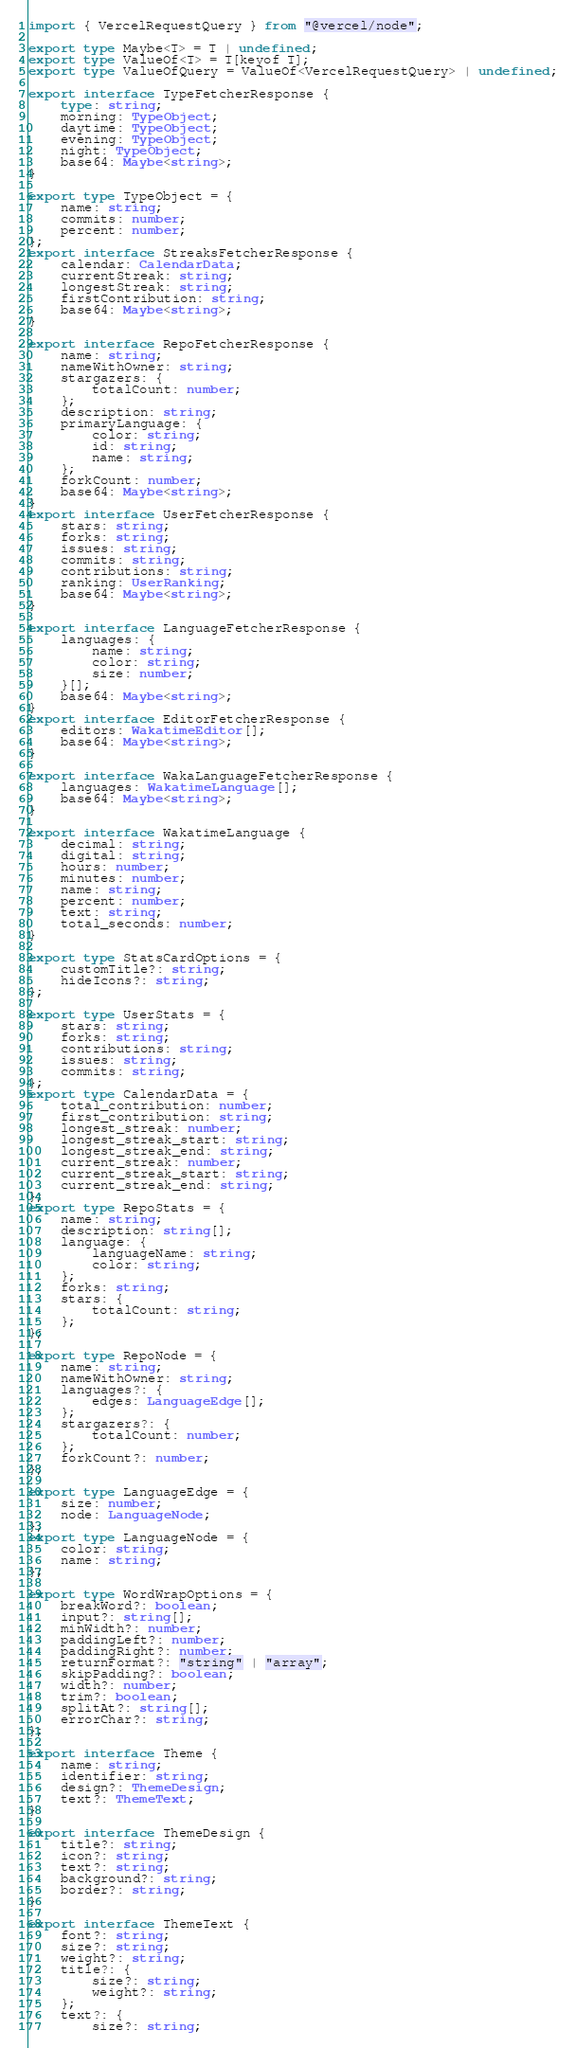Convert code to text. <code><loc_0><loc_0><loc_500><loc_500><_TypeScript_>import { VercelRequestQuery } from "@vercel/node";

export type Maybe<T> = T | undefined;
export type ValueOf<T> = T[keyof T];
export type ValueOfQuery = ValueOf<VercelRequestQuery> | undefined;

export interface TypeFetcherResponse {
    type: string;
    morning: TypeObject;
    daytime: TypeObject;
    evening: TypeObject;
    night: TypeObject;
    base64: Maybe<string>;
}

export type TypeObject = {
    name: string;
    commits: number;
    percent: number;
};
export interface StreaksFetcherResponse {
    calendar: CalendarData;
    currentStreak: string;
    longestStreak: string;
    firstContribution: string;
    base64: Maybe<string>;
}

export interface RepoFetcherResponse {
    name: string;
    nameWithOwner: string;
    stargazers: {
        totalCount: number;
    };
    description: string;
    primaryLanguage: {
        color: string;
        id: string;
        name: string;
    };
    forkCount: number;
    base64: Maybe<string>;
}
export interface UserFetcherResponse {
    stars: string;
    forks: string;
    issues: string;
    commits: string;
    contributions: string;
    ranking: UserRanking;
    base64: Maybe<string>;
}

export interface LanguageFetcherResponse {
    languages: {
        name: string;
        color: string;
        size: number;
    }[];
    base64: Maybe<string>;
}
export interface EditorFetcherResponse {
    editors: WakatimeEditor[];
    base64: Maybe<string>;
}

export interface WakaLanguageFetcherResponse {
    languages: WakatimeLanguage[];
    base64: Maybe<string>;
}

export interface WakatimeLanguage {
    decimal: string;
    digital: string;
    hours: number;
    minutes: number;
    name: string;
    percent: number;
    text: string;
    total_seconds: number;
}

export type StatsCardOptions = {
    customTitle?: string;
    hideIcons?: string;
};

export type UserStats = {
    stars: string;
    forks: string;
    contributions: string;
    issues: string;
    commits: string;
};
export type CalendarData = {
    total_contribution: number;
    first_contribution: string;
    longest_streak: number;
    longest_streak_start: string;
    longest_streak_end: string;
    current_streak: number;
    current_streak_start: string;
    current_streak_end: string;
};
export type RepoStats = {
    name: string;
    description: string[];
    language: {
        languageName: string;
        color: string;
    };
    forks: string;
    stars: {
        totalCount: string;
    };
};

export type RepoNode = {
    name: string;
    nameWithOwner: string;
    languages?: {
        edges: LanguageEdge[];
    };
    stargazers?: {
        totalCount: number;
    };
    forkCount?: number;
};

export type LanguageEdge = {
    size: number;
    node: LanguageNode;
};
export type LanguageNode = {
    color: string;
    name: string;
};

export type WordWrapOptions = {
    breakWord?: boolean;
    input?: string[];
    minWidth?: number;
    paddingLeft?: number;
    paddingRight?: number;
    returnFormat?: "string" | "array";
    skipPadding?: boolean;
    width?: number;
    trim?: boolean;
    splitAt?: string[];
    errorChar?: string;
};

export interface Theme {
    name: string;
    identifier: string;
    design?: ThemeDesign;
    text?: ThemeText;
}

export interface ThemeDesign {
    title?: string;
    icon?: string;
    text?: string;
    background?: string;
    border?: string;
}

export interface ThemeText {
    font?: string;
    size?: string;
    weight?: string;
    title?: {
        size?: string;
        weight?: string;
    };
    text?: {
        size?: string;</code> 